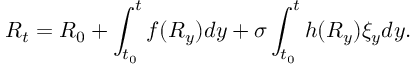Convert formula to latex. <formula><loc_0><loc_0><loc_500><loc_500>R _ { t } = R _ { 0 } + \int _ { t _ { 0 } } ^ { t } f ( R _ { y } ) d y + \sigma \int _ { t _ { 0 } } ^ { t } h ( R _ { y } ) \xi _ { y } d y .</formula> 